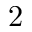Convert formula to latex. <formula><loc_0><loc_0><loc_500><loc_500>2</formula> 